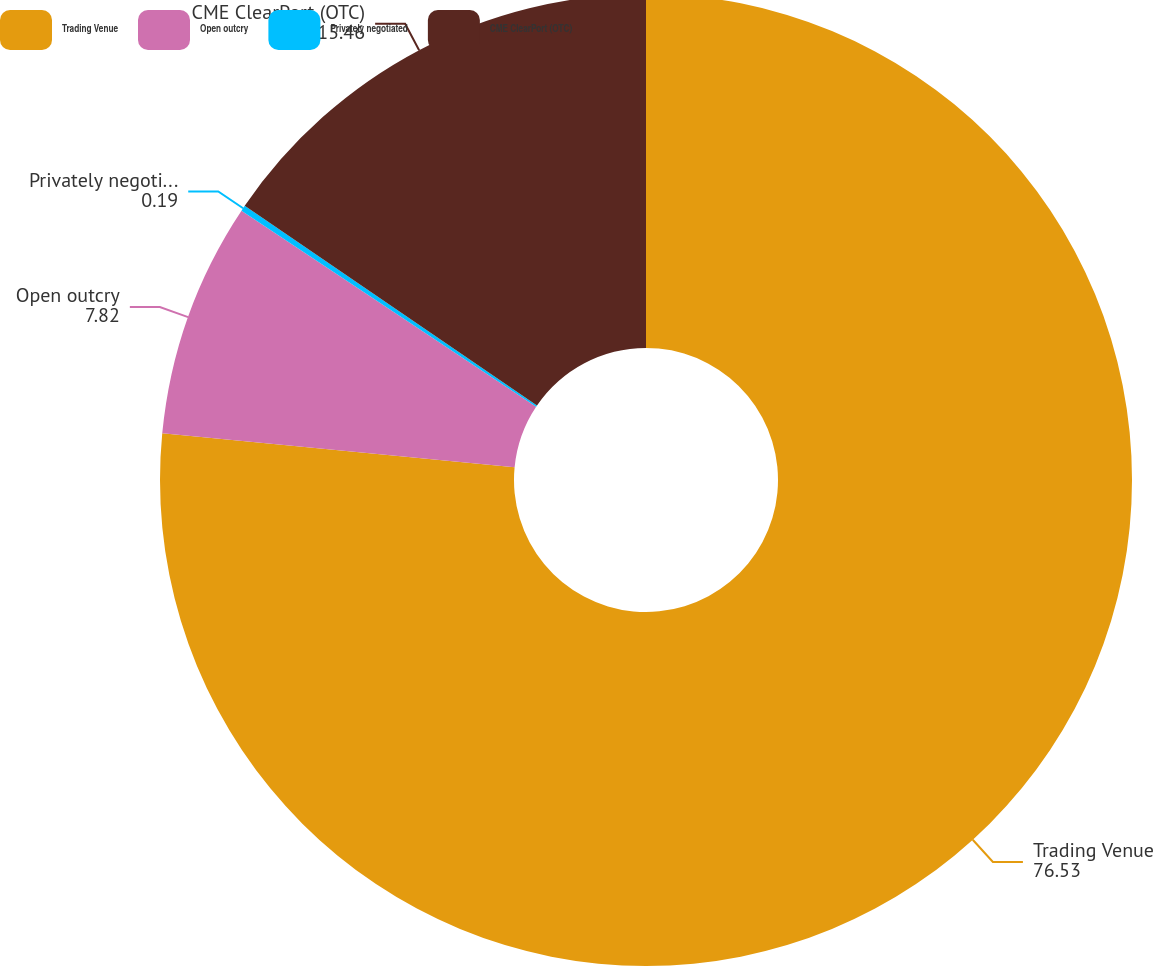Convert chart to OTSL. <chart><loc_0><loc_0><loc_500><loc_500><pie_chart><fcel>Trading Venue<fcel>Open outcry<fcel>Privately negotiated<fcel>CME ClearPort (OTC)<nl><fcel>76.53%<fcel>7.82%<fcel>0.19%<fcel>15.46%<nl></chart> 